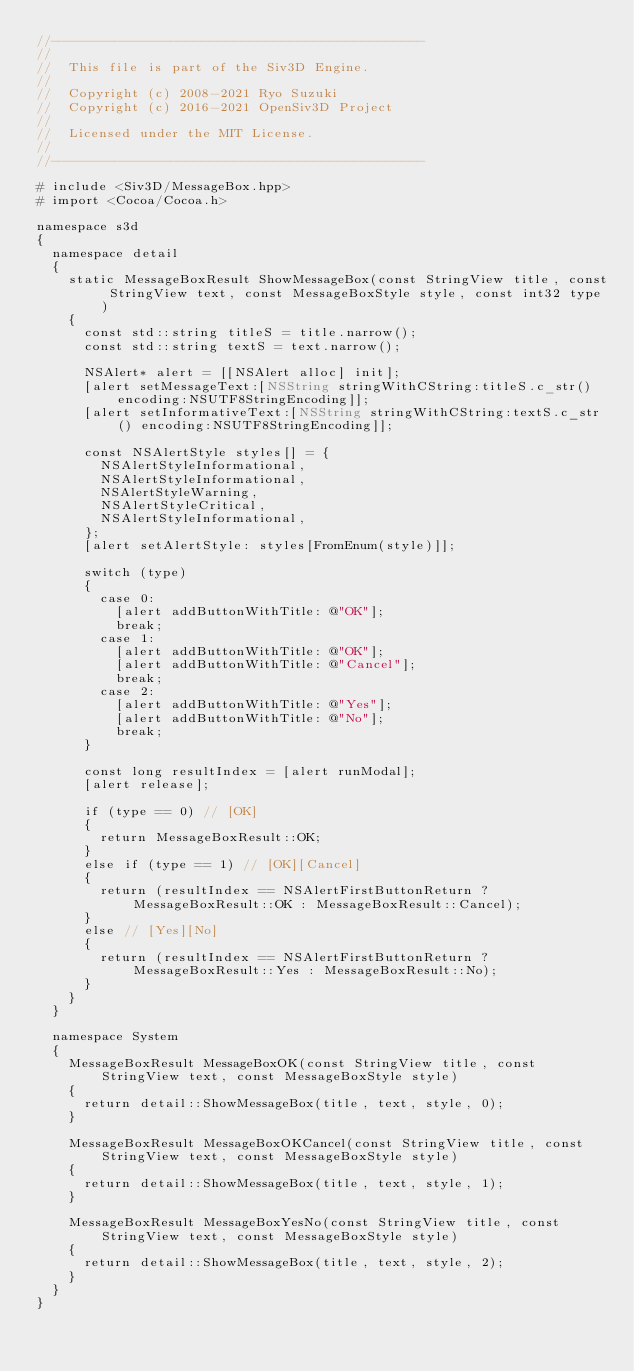Convert code to text. <code><loc_0><loc_0><loc_500><loc_500><_ObjectiveC_>//-----------------------------------------------
//
//	This file is part of the Siv3D Engine.
//
//	Copyright (c) 2008-2021 Ryo Suzuki
//	Copyright (c) 2016-2021 OpenSiv3D Project
//
//	Licensed under the MIT License.
//
//-----------------------------------------------

# include <Siv3D/MessageBox.hpp>
# import <Cocoa/Cocoa.h>

namespace s3d
{
	namespace detail
	{
		static MessageBoxResult ShowMessageBox(const StringView title, const StringView text, const MessageBoxStyle style, const int32 type)
		{
			const std::string titleS = title.narrow();
			const std::string textS = text.narrow();
			
			NSAlert* alert = [[NSAlert alloc] init];
			[alert setMessageText:[NSString stringWithCString:titleS.c_str() encoding:NSUTF8StringEncoding]];
			[alert setInformativeText:[NSString stringWithCString:textS.c_str() encoding:NSUTF8StringEncoding]];
			
			const NSAlertStyle styles[] = {
				NSAlertStyleInformational,
				NSAlertStyleInformational,
				NSAlertStyleWarning,
				NSAlertStyleCritical,
				NSAlertStyleInformational,
			};
			[alert setAlertStyle: styles[FromEnum(style)]];
			
			switch (type)
			{
				case 0:
					[alert addButtonWithTitle: @"OK"];
					break;
				case 1:
					[alert addButtonWithTitle: @"OK"];
					[alert addButtonWithTitle: @"Cancel"];
					break;
				case 2:
					[alert addButtonWithTitle: @"Yes"];
					[alert addButtonWithTitle: @"No"];
					break;
			}
			
			const long resultIndex = [alert runModal];
			[alert release];
			
			if (type == 0) // [OK]
			{
				return MessageBoxResult::OK;
			}
			else if (type == 1) // [OK][Cancel]
			{
				return (resultIndex == NSAlertFirstButtonReturn ? MessageBoxResult::OK : MessageBoxResult::Cancel);
			}
			else // [Yes][No]
			{
				return (resultIndex == NSAlertFirstButtonReturn ? MessageBoxResult::Yes : MessageBoxResult::No);
			}
		}
	}

	namespace System
	{
		MessageBoxResult MessageBoxOK(const StringView title, const StringView text, const MessageBoxStyle style)
		{
			return detail::ShowMessageBox(title, text, style, 0);
		}

		MessageBoxResult MessageBoxOKCancel(const StringView title, const StringView text, const MessageBoxStyle style)
		{
			return detail::ShowMessageBox(title, text, style, 1);
		}

		MessageBoxResult MessageBoxYesNo(const StringView title, const StringView text, const MessageBoxStyle style)
		{
			return detail::ShowMessageBox(title, text, style, 2);
		}
	}
}
</code> 